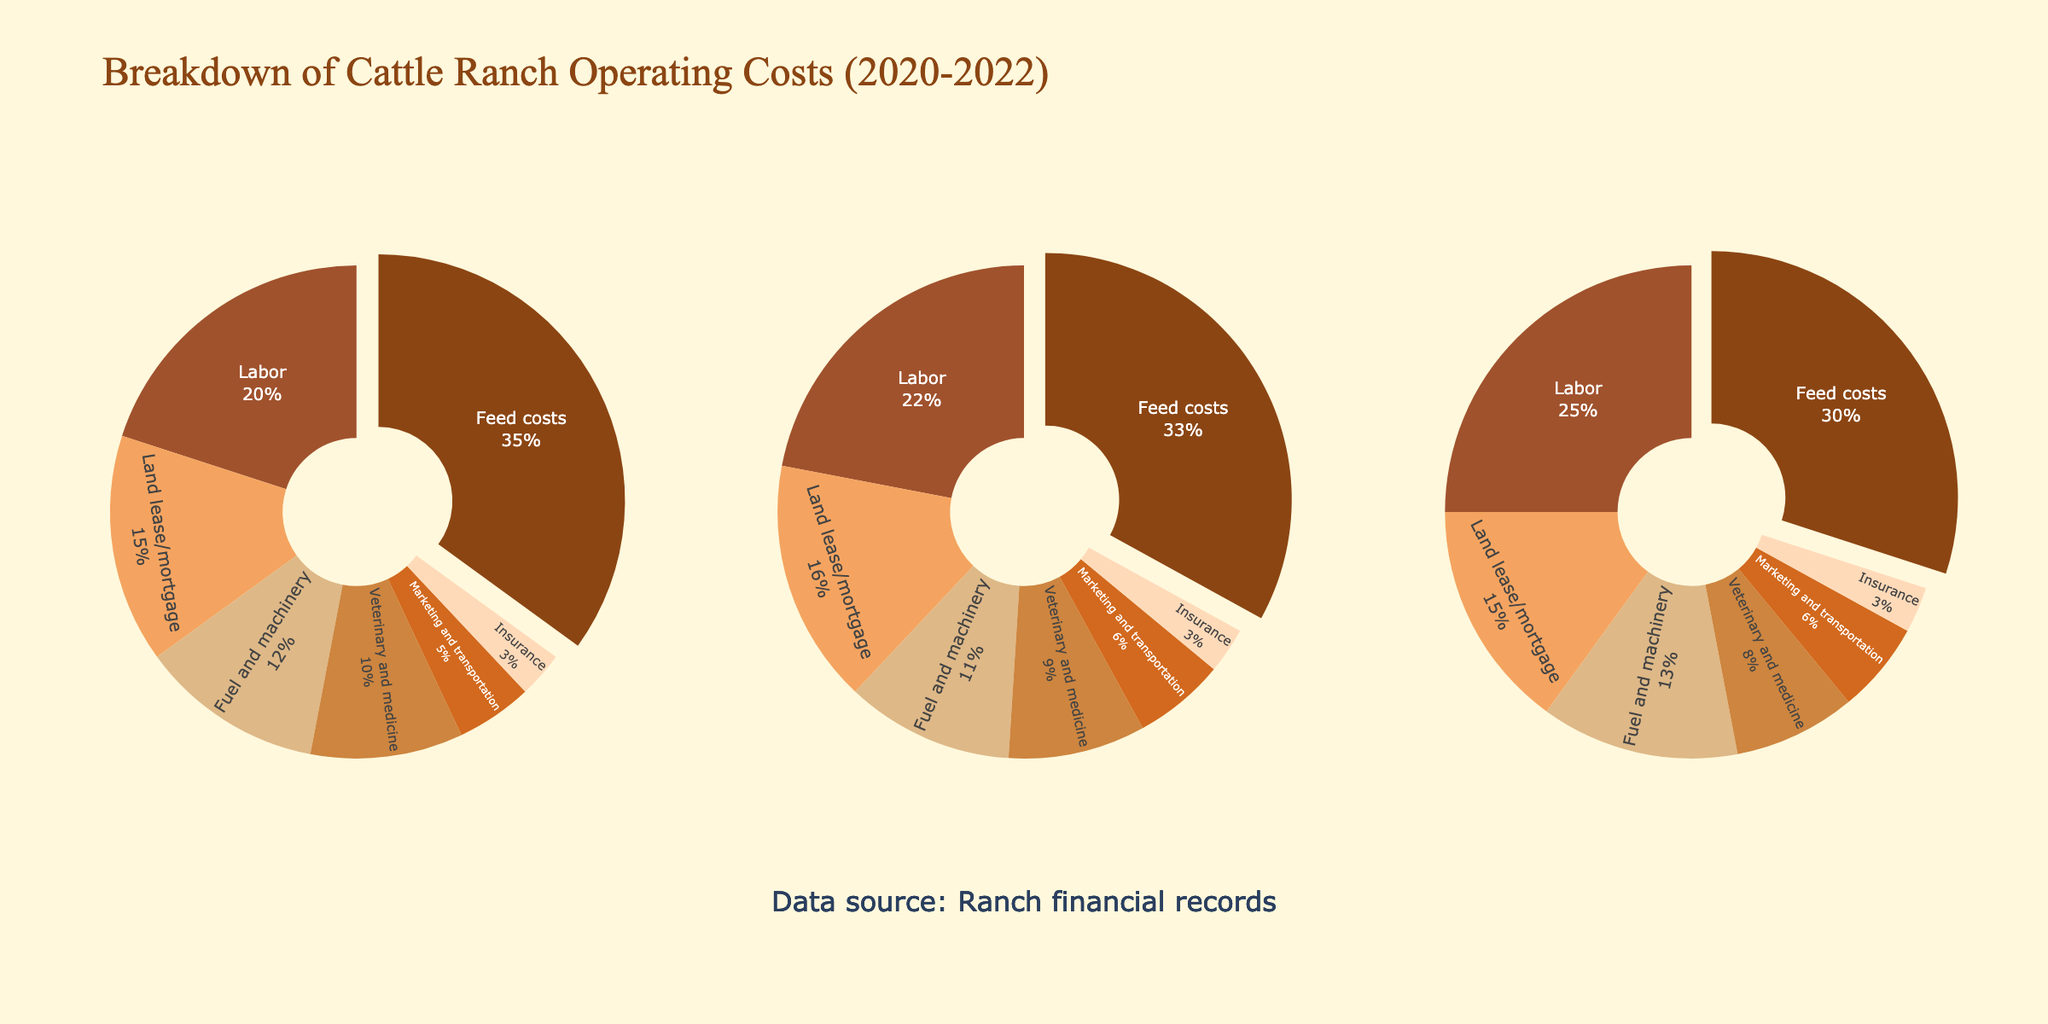What is the title of the figure? The title of the figure is displayed at the top center of the plot. It reads "Breakdown of Cattle Ranch Operating Costs (2020-2022)".
Answer: Breakdown of Cattle Ranch Operating Costs (2020-2022) Which category had the highest percentage of costs in 2021? In the 2021 pie chart, the Feed costs segment is the largest, indicating it had the highest percentage.
Answer: Feed costs How did the percentage of Labor costs change from 2020 to 2022? By comparing the Labor segments of the 2020 and 2022 pie charts, we see that it decreased from 25% in 2020 to 20% in 2022.
Answer: Decreased by 5% What is the combined percentage of Fuel and machinery and Veterinary and medicine costs in 2022? In the 2022 pie chart, Fuel and machinery is 12% and Veterinary and medicine is 10%. The combined percentage is 12 + 10 = 22%.
Answer: 22% Which year had the lowest percentage for Insurance costs? The Insurance segment remains the same size across all three pie charts, indicating it is 3% for each year. There is no year with a lower percentage.
Answer: All years have the same percentage How do the Feed costs for 2021 compare to 2020? By comparing the Feed costs segments in the 2020 and 2021 pie charts, we see it increased from 30% in 2020 to 33% in 2021.
Answer: Increased by 3% What is the total percentage accounted for by Feed costs and Labor in 2020? Summing the percentages of Feed costs (30%) and Labor (25%) in the 2020 pie chart results in 30 + 25 = 55%.
Answer: 55% Which category saw the biggest percentage increase in 2022 compared to 2021? By comparing each category between 2021 and 2022, Feed costs increased the most from 33% to 35%, a 2% increase.
Answer: Feed costs Is the percentage of Marketing and transportation costs in 2021 higher, lower, or the same as in 2022? By comparing the Marketing and transportation segments in 2021 (6%) and 2022 (5%), we see that it is lower in 2022.
Answer: Lower 